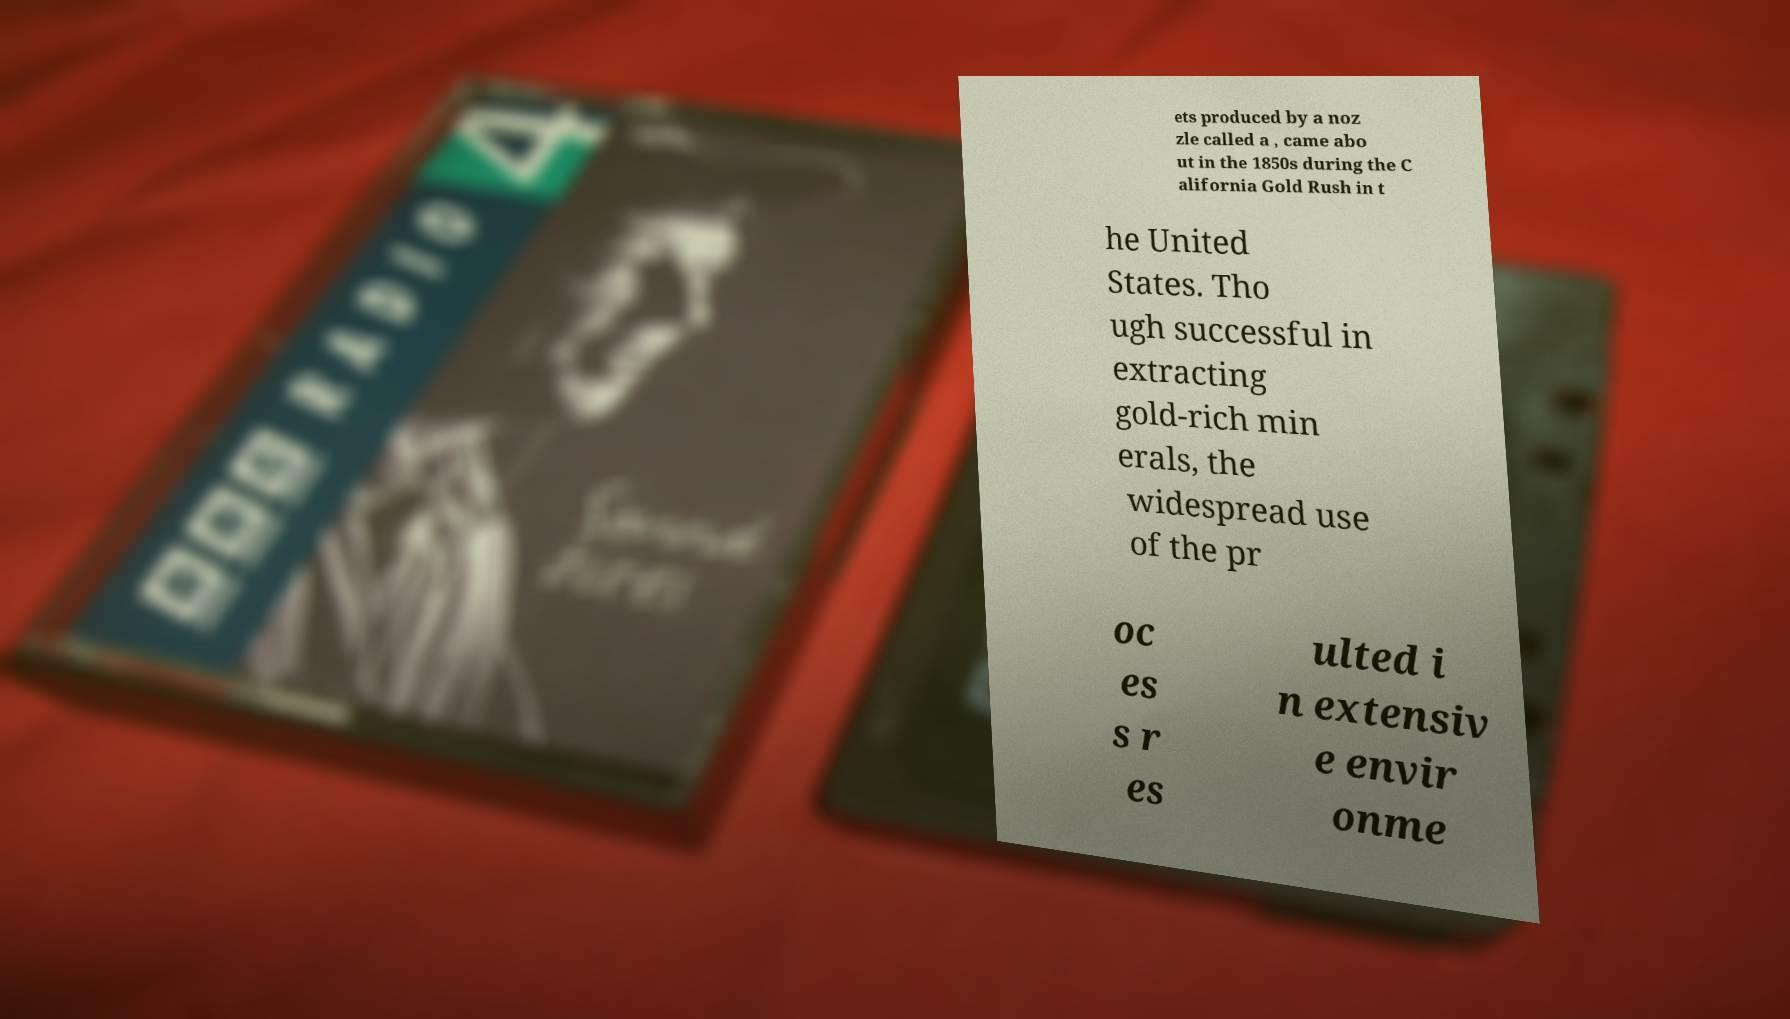Could you extract and type out the text from this image? ets produced by a noz zle called a , came abo ut in the 1850s during the C alifornia Gold Rush in t he United States. Tho ugh successful in extracting gold-rich min erals, the widespread use of the pr oc es s r es ulted i n extensiv e envir onme 